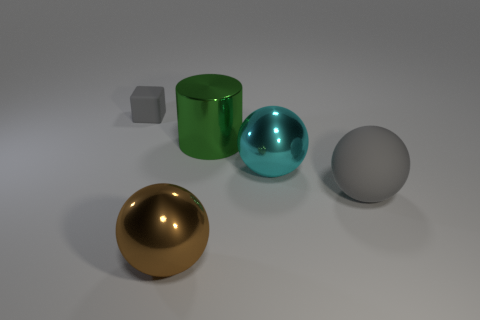What size is the rubber thing that is the same color as the rubber cube?
Provide a succinct answer. Large. What is the material of the gray thing that is to the left of the matte object that is on the right side of the big green cylinder?
Keep it short and to the point. Rubber. What shape is the large green metal object?
Your response must be concise. Cylinder. Are there an equal number of big cyan shiny spheres that are on the right side of the big cyan metal object and big shiny things in front of the tiny cube?
Make the answer very short. No. Is the color of the thing that is on the left side of the brown shiny thing the same as the matte object in front of the matte cube?
Ensure brevity in your answer.  Yes. Is the number of spheres in front of the cyan metallic ball greater than the number of big green cylinders?
Offer a very short reply. Yes. The brown object that is made of the same material as the cyan object is what shape?
Offer a terse response. Sphere. There is a gray thing behind the metallic cylinder; does it have the same size as the large shiny cylinder?
Your answer should be very brief. No. What shape is the matte object that is behind the gray rubber thing right of the matte block?
Your answer should be very brief. Cube. What is the size of the metal ball behind the gray rubber thing that is in front of the cube?
Your answer should be compact. Large. 